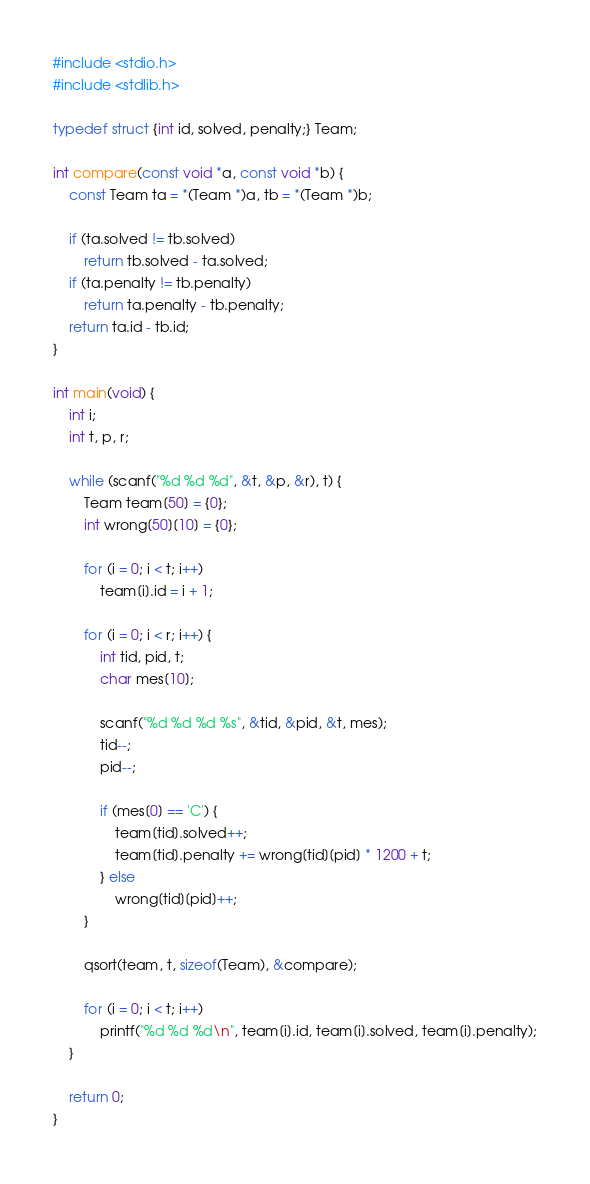Convert code to text. <code><loc_0><loc_0><loc_500><loc_500><_C_>#include <stdio.h>
#include <stdlib.h>

typedef struct {int id, solved, penalty;} Team;

int compare(const void *a, const void *b) {
	const Team ta = *(Team *)a, tb = *(Team *)b;

	if (ta.solved != tb.solved)
		return tb.solved - ta.solved;
	if (ta.penalty != tb.penalty)
		return ta.penalty - tb.penalty;
	return ta.id - tb.id;
}

int main(void) {
	int i;
	int t, p, r;

	while (scanf("%d %d %d", &t, &p, &r), t) {
		Team team[50] = {0};
		int wrong[50][10] = {0};

		for (i = 0; i < t; i++)
			team[i].id = i + 1;

		for (i = 0; i < r; i++) {
			int tid, pid, t;
			char mes[10];

			scanf("%d %d %d %s", &tid, &pid, &t, mes);
			tid--;
			pid--;

			if (mes[0] == 'C') {
				team[tid].solved++;
				team[tid].penalty += wrong[tid][pid] * 1200 + t;
			} else
				wrong[tid][pid]++;
		}

		qsort(team, t, sizeof(Team), &compare);

		for (i = 0; i < t; i++)
			printf("%d %d %d\n", team[i].id, team[i].solved, team[i].penalty);
	}

	return 0;
}</code> 